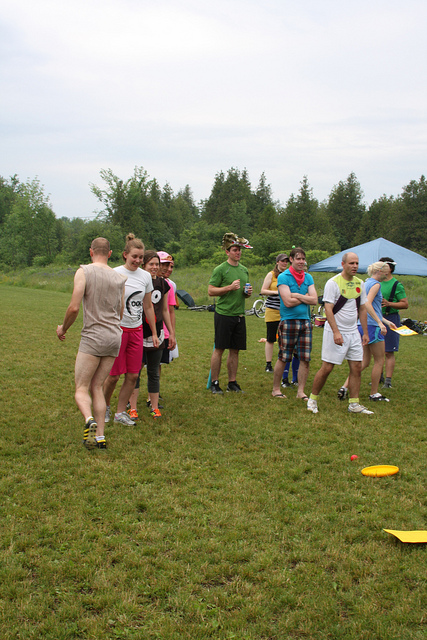Describe the following image. In the image, a group of around ten people is standing together on a grassy field. Most of them are wearing casual sporty attire, including short pants and socks, with some individuals in bright or distinct clothing items like pink shorts or colorful bandanas. The background features a tent and a forested area, suggesting this could be a camping or recreational event. On the ground near the group, there are a couple of frisbees, indicating that the group might be preparing for or engaged in an outdoor activity, such as a game of frisbee. The atmosphere appears casual and friendly. 